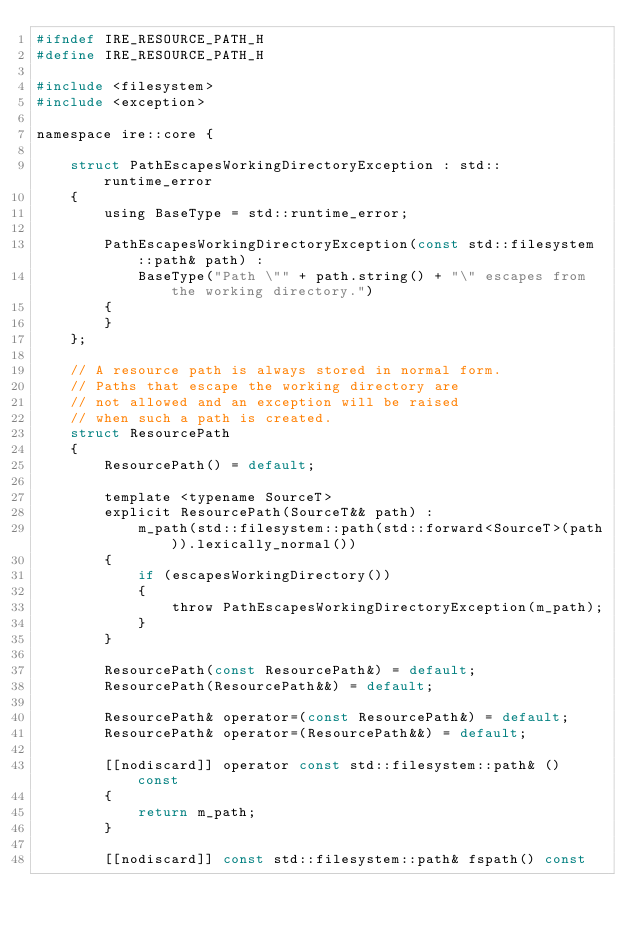Convert code to text. <code><loc_0><loc_0><loc_500><loc_500><_C_>#ifndef IRE_RESOURCE_PATH_H
#define IRE_RESOURCE_PATH_H

#include <filesystem>
#include <exception>

namespace ire::core {

    struct PathEscapesWorkingDirectoryException : std::runtime_error
    {
        using BaseType = std::runtime_error;

        PathEscapesWorkingDirectoryException(const std::filesystem::path& path) :
            BaseType("Path \"" + path.string() + "\" escapes from the working directory.")
        {
        }
    };

    // A resource path is always stored in normal form.
    // Paths that escape the working directory are
    // not allowed and an exception will be raised
    // when such a path is created.
    struct ResourcePath
    {
        ResourcePath() = default;

        template <typename SourceT>
        explicit ResourcePath(SourceT&& path) :
            m_path(std::filesystem::path(std::forward<SourceT>(path)).lexically_normal())
        {
            if (escapesWorkingDirectory())
            {
                throw PathEscapesWorkingDirectoryException(m_path);
            }
        }

        ResourcePath(const ResourcePath&) = default;
        ResourcePath(ResourcePath&&) = default;

        ResourcePath& operator=(const ResourcePath&) = default;
        ResourcePath& operator=(ResourcePath&&) = default;

        [[nodiscard]] operator const std::filesystem::path& () const
        {
            return m_path;
        }

        [[nodiscard]] const std::filesystem::path& fspath() const</code> 